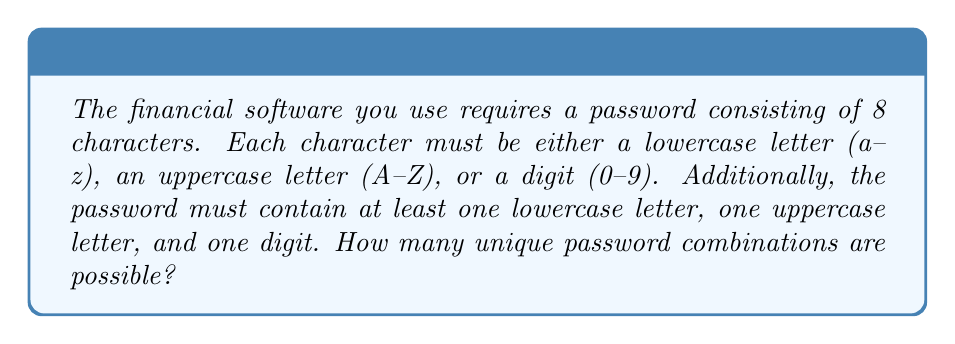Can you solve this math problem? Let's approach this step-by-step:

1) First, we need to calculate the total number of characters available:
   - 26 lowercase letters
   - 26 uppercase letters
   - 10 digits
   Total: 26 + 26 + 10 = 62 characters

2) If there were no restrictions, we would have $62^8$ possible combinations.

3) However, we need to subtract the combinations that don't meet our criteria:
   a) Passwords with no lowercase letters
   b) Passwords with no uppercase letters
   c) Passwords with no digits

4) Let's calculate these:
   a) No lowercase: $36^8$ (only uppercase and digits)
   b) No uppercase: $36^8$ (only lowercase and digits)
   c) No digits: $52^8$ (only lowercase and uppercase)

5) However, if we simply subtract these from the total, we'll have subtracted some combinations twice. We need to add back:
   d) Passwords with only uppercase: $26^8$
   e) Passwords with only lowercase: $26^8$
   f) Passwords with only digits: $10^8$

6) The final formula is:
   $$ 62^8 - 36^8 - 36^8 - 52^8 + 26^8 + 26^8 + 10^8 $$

7) Calculating this:
   $$ 218,340,105,584,896 - 2,821,109,907,456 - 2,821,109,907,456 - 53,459,728,531,456 + 208,827,064,576 + 208,827,064,576 + 100,000,000 $$
   $$ = 159,654,908,170,680 $$
Answer: 159,654,908,170,680 